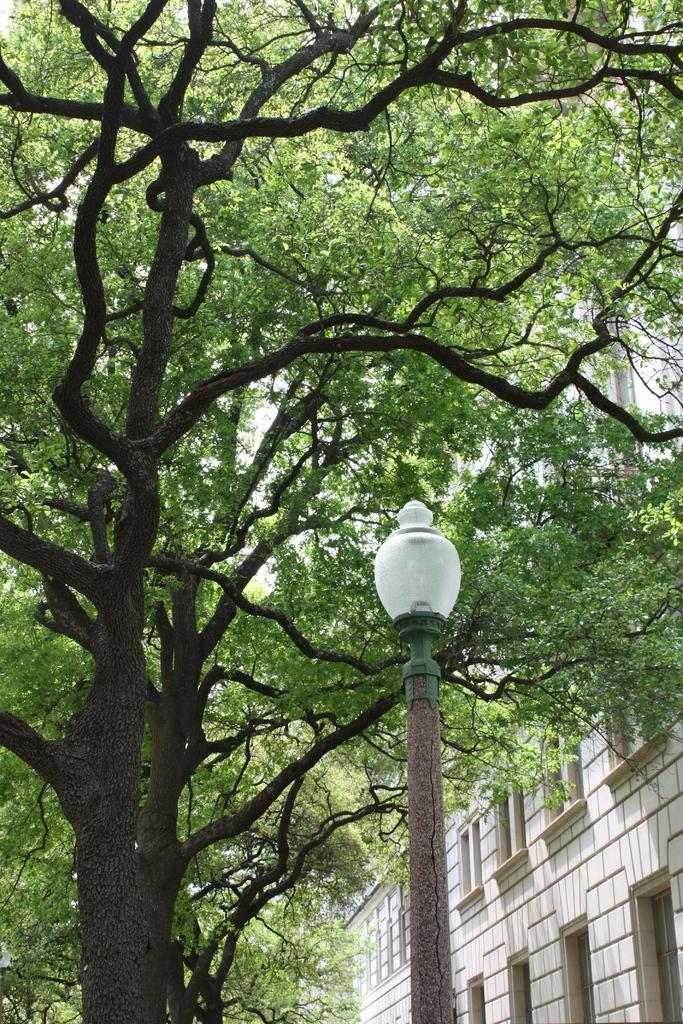Describe this image in one or two sentences. This picture might be taken from outside of the city and it is sunny. In this image on the right side, we can see a building and windows. In the middle of the image, we can see a street light. On the left side, we can see some trees. 